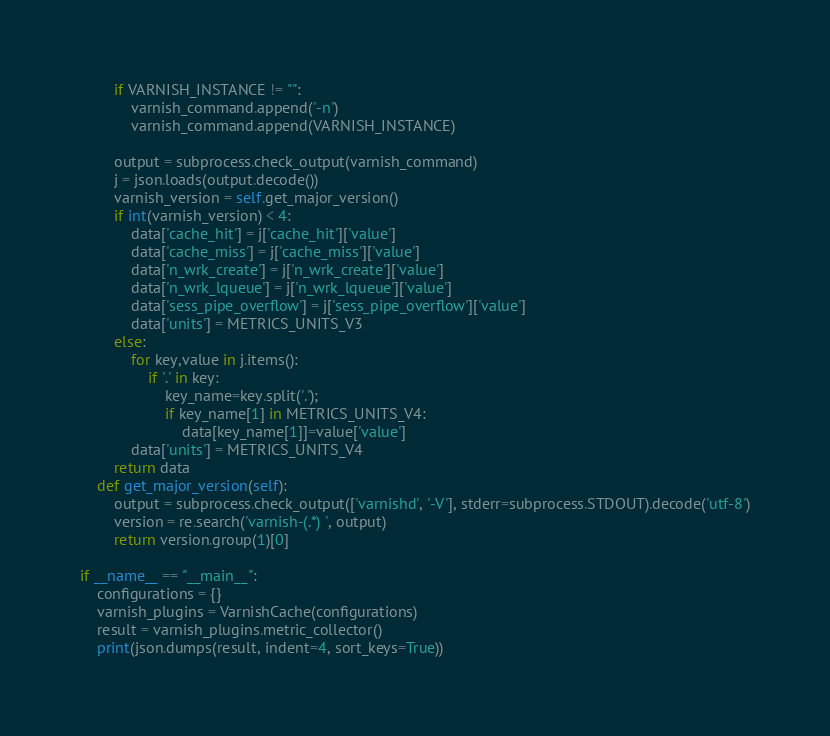<code> <loc_0><loc_0><loc_500><loc_500><_Python_>
        if VARNISH_INSTANCE != "":
            varnish_command.append('-n')
            varnish_command.append(VARNISH_INSTANCE)    

        output = subprocess.check_output(varnish_command)
        j = json.loads(output.decode())
        varnish_version = self.get_major_version()
        if int(varnish_version) < 4:
            data['cache_hit'] = j['cache_hit']['value']
            data['cache_miss'] = j['cache_miss']['value']
            data['n_wrk_create'] = j['n_wrk_create']['value']
            data['n_wrk_lqueue'] = j['n_wrk_lqueue']['value']
            data['sess_pipe_overflow'] = j['sess_pipe_overflow']['value']
            data['units'] = METRICS_UNITS_V3
        else:
            for key,value in j.items():            
                if '.' in key:
                    key_name=key.split('.');
                    if key_name[1] in METRICS_UNITS_V4:
                        data[key_name[1]]=value['value']
            data['units'] = METRICS_UNITS_V4
        return data
    def get_major_version(self):
        output = subprocess.check_output(['varnishd', '-V'], stderr=subprocess.STDOUT).decode('utf-8')
        version = re.search('varnish-(.*) ', output)
        return version.group(1)[0]

if __name__ == "__main__":
    configurations = {}
    varnish_plugins = VarnishCache(configurations)
    result = varnish_plugins.metric_collector()
    print(json.dumps(result, indent=4, sort_keys=True))

</code> 